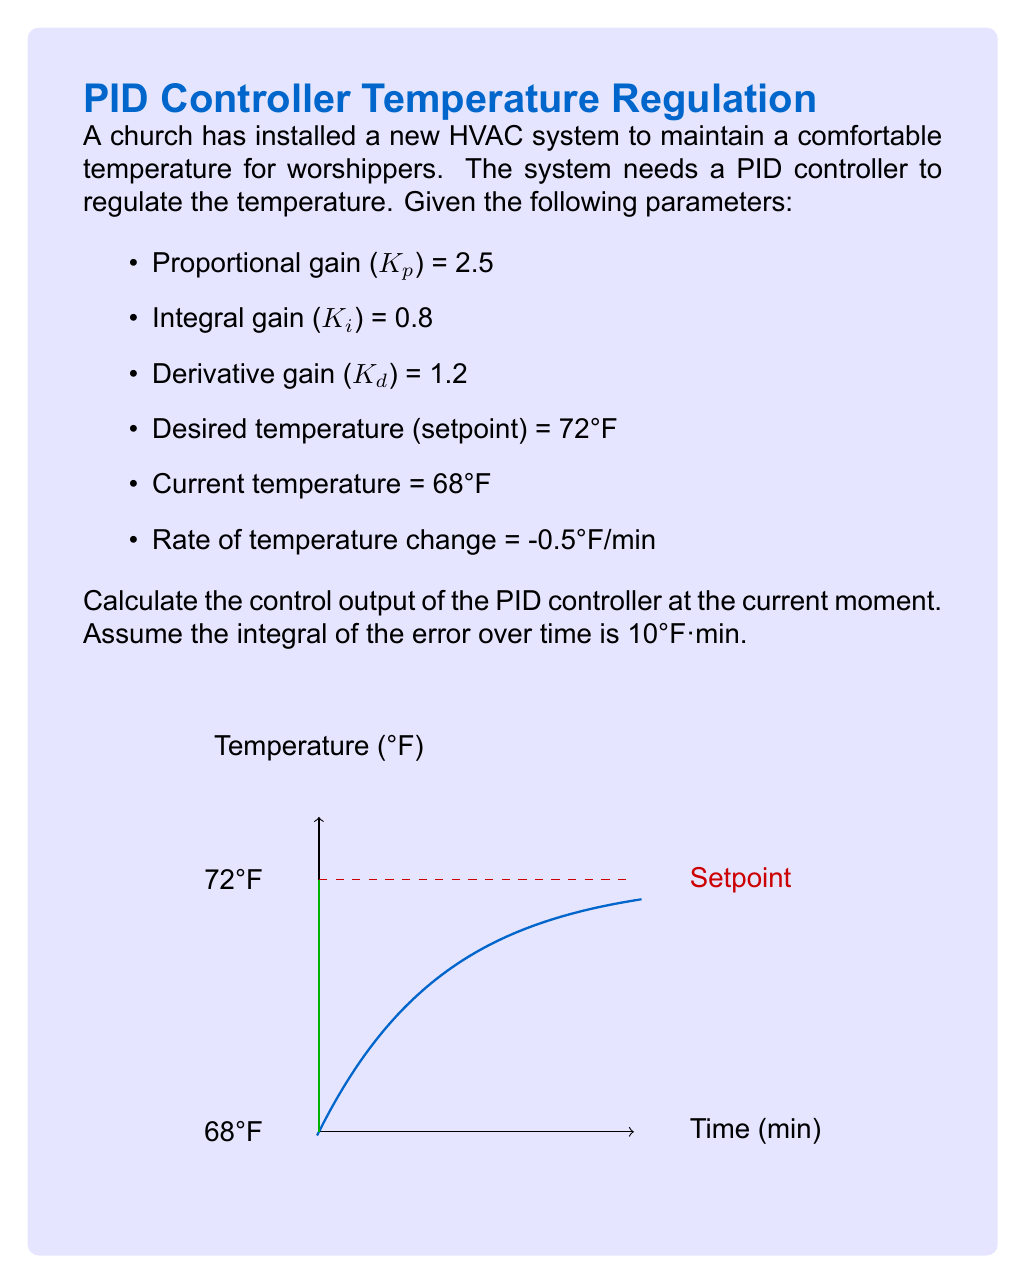What is the answer to this math problem? Let's approach this step-by-step using the PID controller equation:

1) The PID controller equation is:
   $$u(t) = K_p e(t) + K_i \int_0^t e(\tau) d\tau + K_d \frac{de(t)}{dt}$$

2) Calculate the error (e):
   $e = \text{Setpoint} - \text{Current temperature} = 72°F - 68°F = 4°F$

3) The integral of the error is given as 10°F·min.

4) The derivative of the error is the negative of the rate of temperature change:
   $\frac{de}{dt} = -(-0.5°F/min) = 0.5°F/min$

5) Now, let's substitute these values into the PID equation:

   $$\begin{align}
   u(t) &= K_p e + K_i \int e(t) dt + K_d \frac{de}{dt} \\
   &= 2.5 \cdot 4 + 0.8 \cdot 10 + 1.2 \cdot 0.5 \\
   &= 10 + 8 + 0.6 \\
   &= 18.6
   \end{align}$$

6) The units of the control output depend on the specific actuator being controlled (e.g., valve position, fan speed), so we'll leave it as a dimensionless value.
Answer: 18.6 